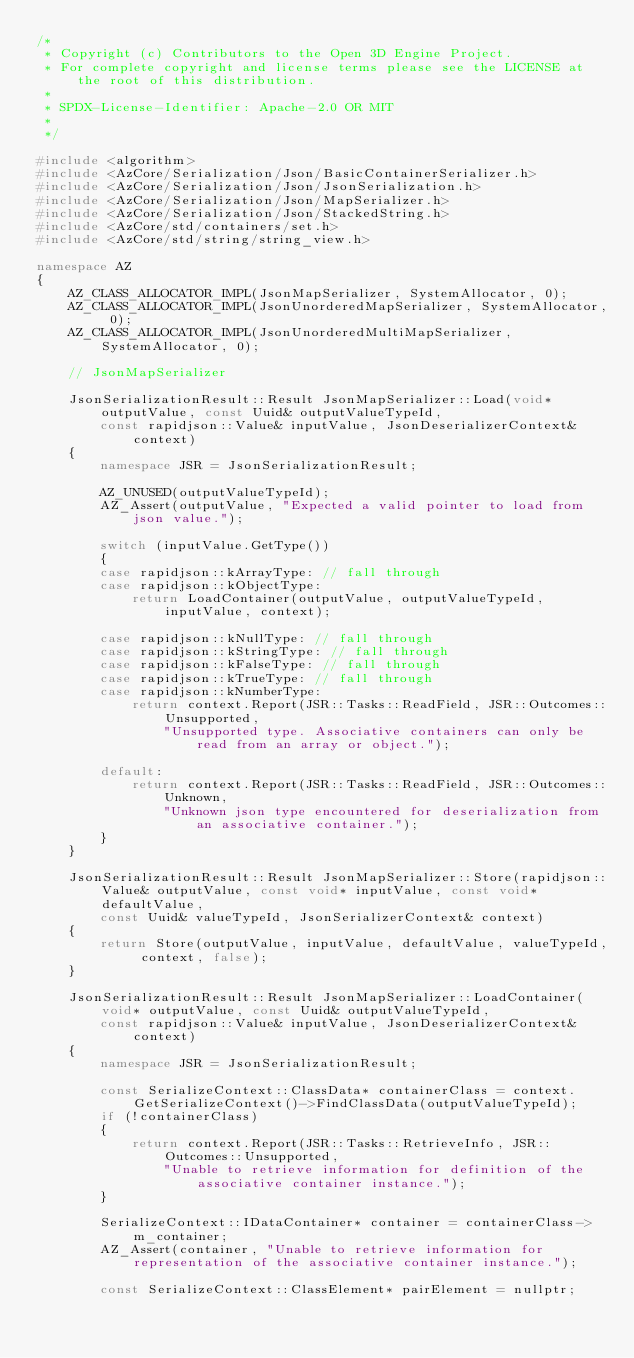<code> <loc_0><loc_0><loc_500><loc_500><_C++_>/*
 * Copyright (c) Contributors to the Open 3D Engine Project.
 * For complete copyright and license terms please see the LICENSE at the root of this distribution.
 *
 * SPDX-License-Identifier: Apache-2.0 OR MIT
 *
 */

#include <algorithm>
#include <AzCore/Serialization/Json/BasicContainerSerializer.h>
#include <AzCore/Serialization/Json/JsonSerialization.h>
#include <AzCore/Serialization/Json/MapSerializer.h>
#include <AzCore/Serialization/Json/StackedString.h>
#include <AzCore/std/containers/set.h>
#include <AzCore/std/string/string_view.h>

namespace AZ
{
    AZ_CLASS_ALLOCATOR_IMPL(JsonMapSerializer, SystemAllocator, 0);
    AZ_CLASS_ALLOCATOR_IMPL(JsonUnorderedMapSerializer, SystemAllocator, 0);
    AZ_CLASS_ALLOCATOR_IMPL(JsonUnorderedMultiMapSerializer, SystemAllocator, 0);
    
    // JsonMapSerializer

    JsonSerializationResult::Result JsonMapSerializer::Load(void* outputValue, const Uuid& outputValueTypeId,
        const rapidjson::Value& inputValue, JsonDeserializerContext& context)
    {
        namespace JSR = JsonSerializationResult;

        AZ_UNUSED(outputValueTypeId);
        AZ_Assert(outputValue, "Expected a valid pointer to load from json value.");

        switch (inputValue.GetType())
        {
        case rapidjson::kArrayType: // fall through
        case rapidjson::kObjectType: 
            return LoadContainer(outputValue, outputValueTypeId, inputValue, context);

        case rapidjson::kNullType: // fall through
        case rapidjson::kStringType: // fall through
        case rapidjson::kFalseType: // fall through
        case rapidjson::kTrueType: // fall through
        case rapidjson::kNumberType:
            return context.Report(JSR::Tasks::ReadField, JSR::Outcomes::Unsupported,
                "Unsupported type. Associative containers can only be read from an array or object.");

        default:
            return context.Report(JSR::Tasks::ReadField, JSR::Outcomes::Unknown,
                "Unknown json type encountered for deserialization from an associative container.");
        }
    }

    JsonSerializationResult::Result JsonMapSerializer::Store(rapidjson::Value& outputValue, const void* inputValue, const void* defaultValue,
        const Uuid& valueTypeId, JsonSerializerContext& context)
    {
        return Store(outputValue, inputValue, defaultValue, valueTypeId, context, false);
    }

    JsonSerializationResult::Result JsonMapSerializer::LoadContainer(void* outputValue, const Uuid& outputValueTypeId,
        const rapidjson::Value& inputValue, JsonDeserializerContext& context)
    {
        namespace JSR = JsonSerializationResult;

        const SerializeContext::ClassData* containerClass = context.GetSerializeContext()->FindClassData(outputValueTypeId);
        if (!containerClass)
        {
            return context.Report(JSR::Tasks::RetrieveInfo, JSR::Outcomes::Unsupported,
                "Unable to retrieve information for definition of the associative container instance.");
        }

        SerializeContext::IDataContainer* container = containerClass->m_container;
        AZ_Assert(container, "Unable to retrieve information for representation of the associative container instance.");
        
        const SerializeContext::ClassElement* pairElement = nullptr;</code> 